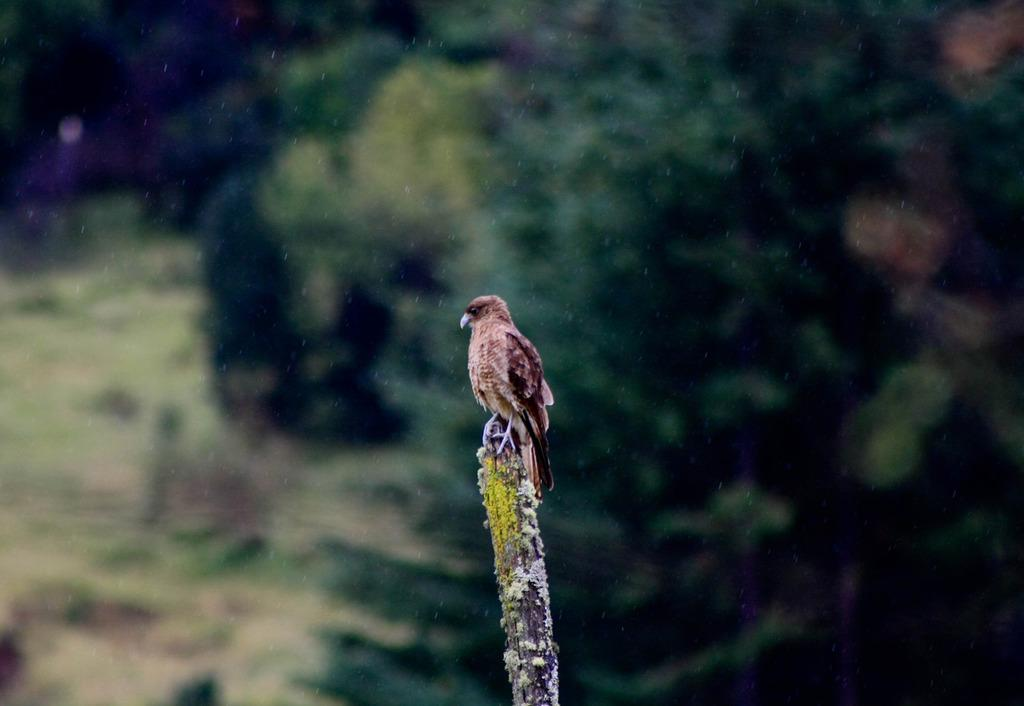What type of animal is in the image? There is a bird in the image. Where is the bird located? The bird is sitting on a wooden pole. What can be seen in the background of the image? The background is green and blurred. What type of hook is the bird using to climb the wooden pole? There is no hook present in the image, and the bird is not climbing the pole. 